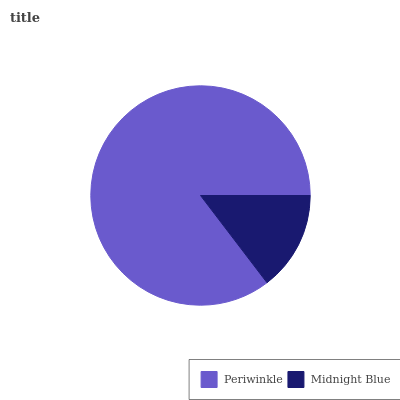Is Midnight Blue the minimum?
Answer yes or no. Yes. Is Periwinkle the maximum?
Answer yes or no. Yes. Is Midnight Blue the maximum?
Answer yes or no. No. Is Periwinkle greater than Midnight Blue?
Answer yes or no. Yes. Is Midnight Blue less than Periwinkle?
Answer yes or no. Yes. Is Midnight Blue greater than Periwinkle?
Answer yes or no. No. Is Periwinkle less than Midnight Blue?
Answer yes or no. No. Is Periwinkle the high median?
Answer yes or no. Yes. Is Midnight Blue the low median?
Answer yes or no. Yes. Is Midnight Blue the high median?
Answer yes or no. No. Is Periwinkle the low median?
Answer yes or no. No. 